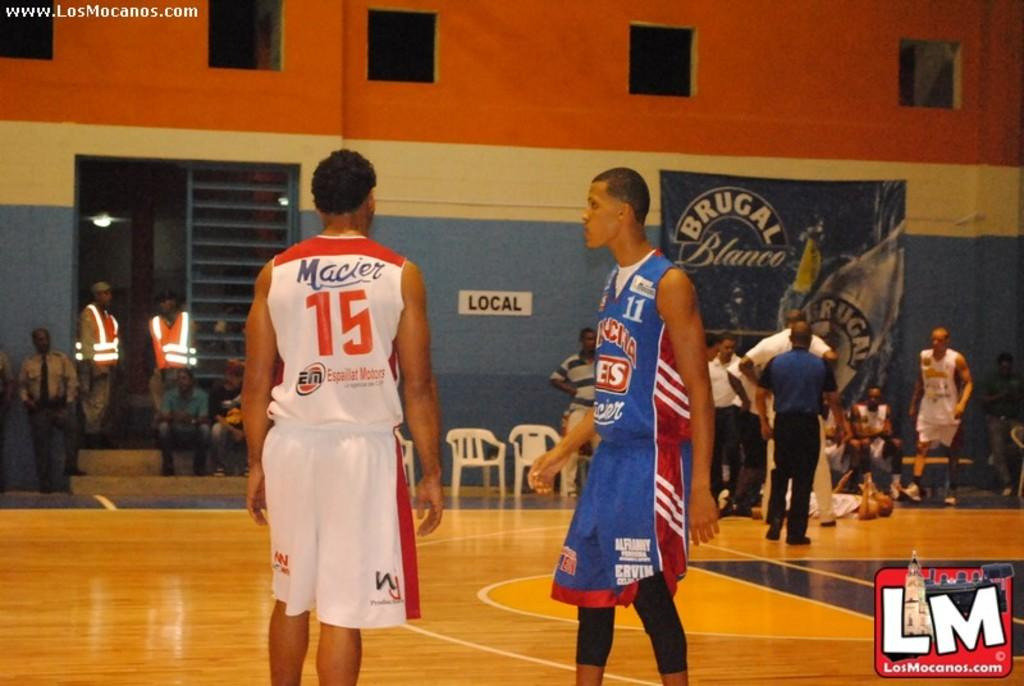<image>
Write a terse but informative summary of the picture. Basketball player wearing a white number 15 jersey standing on the court. 